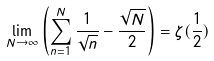Convert formula to latex. <formula><loc_0><loc_0><loc_500><loc_500>\lim _ { N \to \infty } \left ( \sum _ { n = 1 } ^ { N } \frac { 1 } { \sqrt { n } } - \frac { \sqrt { N } } { 2 } \right ) = \zeta ( \frac { 1 } { 2 } )</formula> 